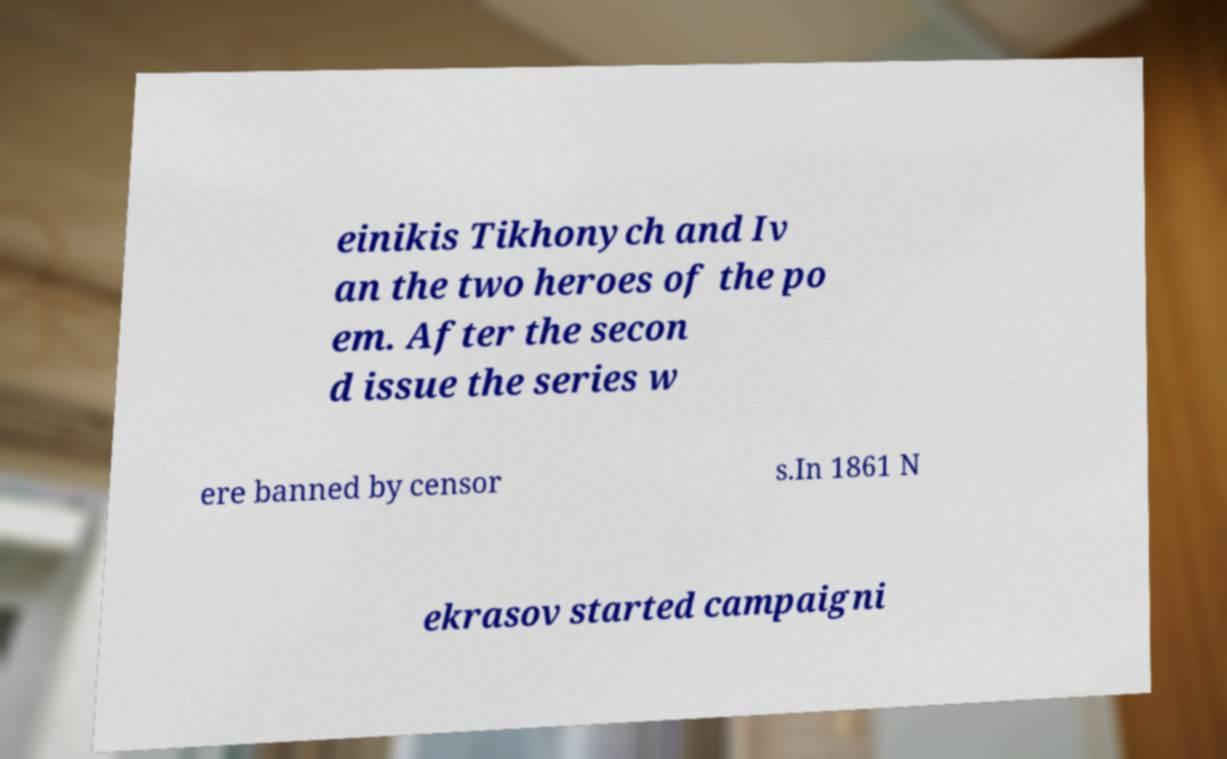Could you extract and type out the text from this image? einikis Tikhonych and Iv an the two heroes of the po em. After the secon d issue the series w ere banned by censor s.In 1861 N ekrasov started campaigni 